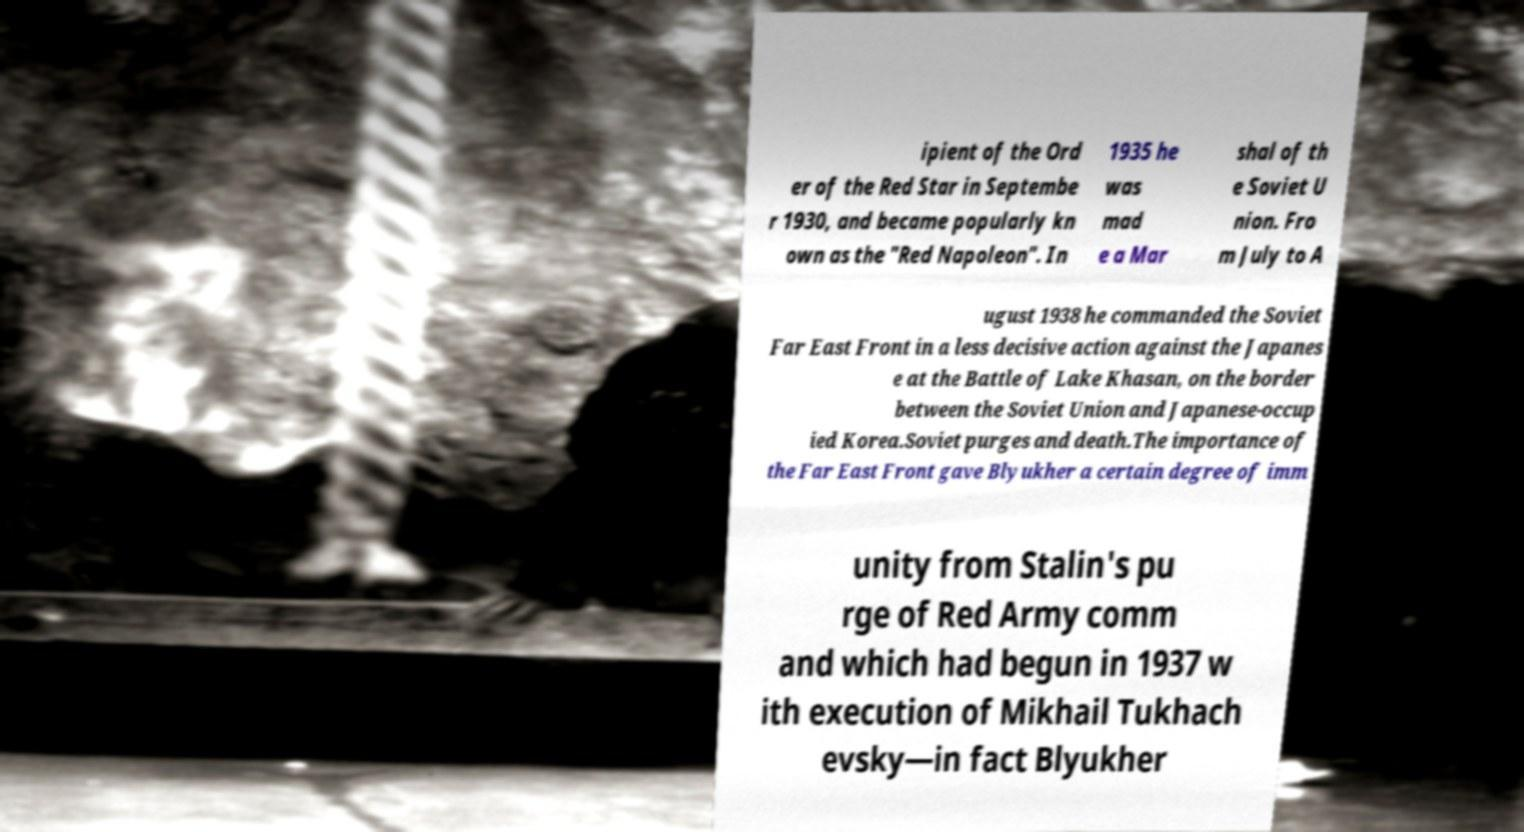Can you accurately transcribe the text from the provided image for me? ipient of the Ord er of the Red Star in Septembe r 1930, and became popularly kn own as the "Red Napoleon". In 1935 he was mad e a Mar shal of th e Soviet U nion. Fro m July to A ugust 1938 he commanded the Soviet Far East Front in a less decisive action against the Japanes e at the Battle of Lake Khasan, on the border between the Soviet Union and Japanese-occup ied Korea.Soviet purges and death.The importance of the Far East Front gave Blyukher a certain degree of imm unity from Stalin's pu rge of Red Army comm and which had begun in 1937 w ith execution of Mikhail Tukhach evsky—in fact Blyukher 